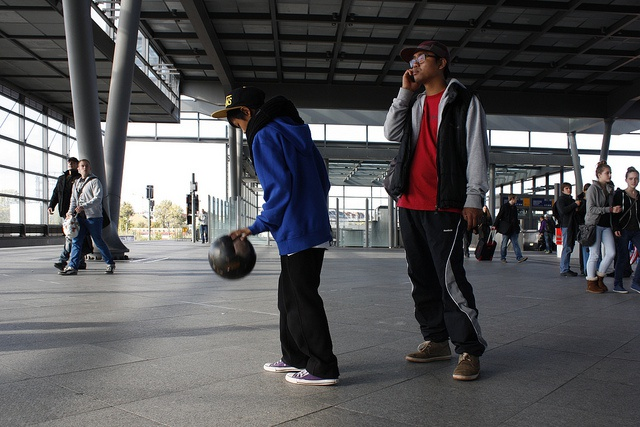Describe the objects in this image and their specific colors. I can see people in black, gray, maroon, and darkgray tones, people in black, navy, darkblue, and blue tones, people in black, gray, darkgray, and lightgray tones, people in black and gray tones, and people in black, gray, darkgray, and maroon tones in this image. 